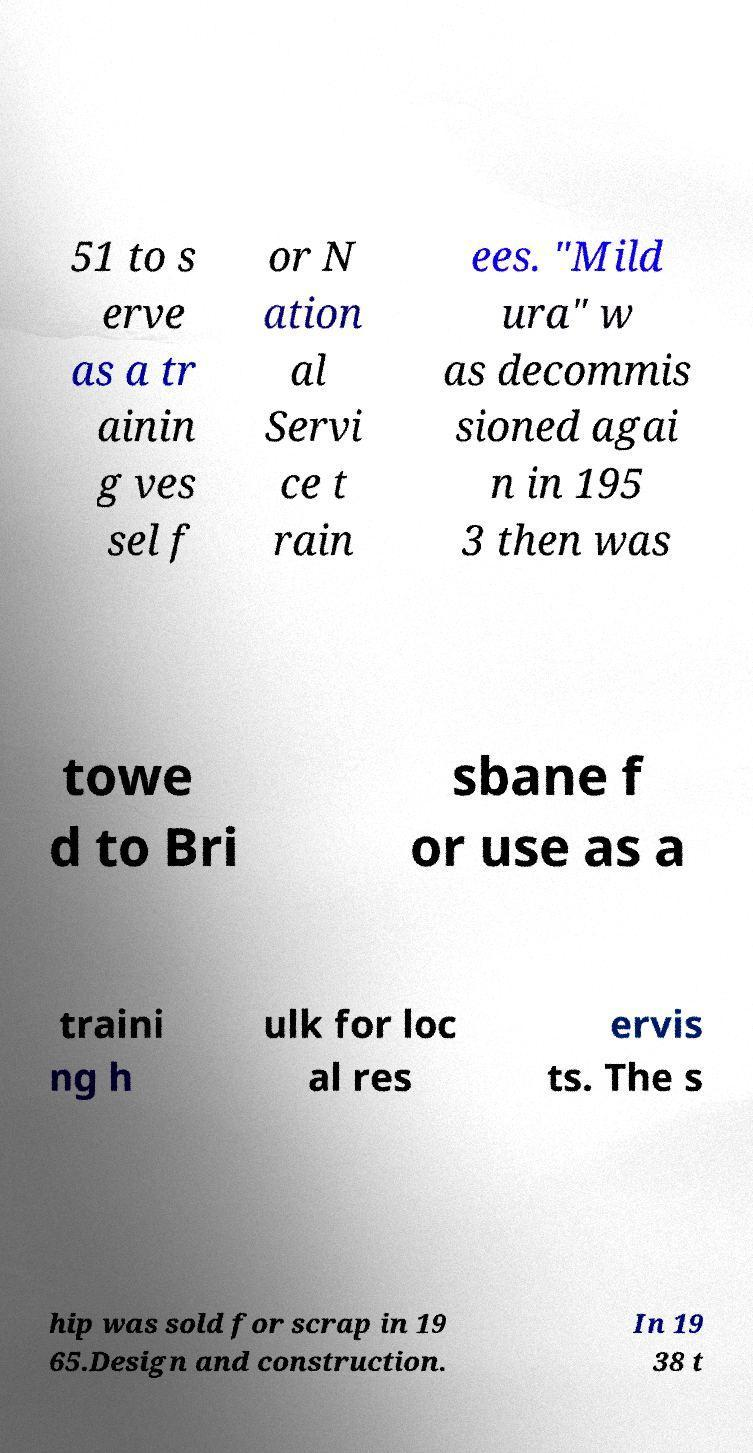Can you read and provide the text displayed in the image?This photo seems to have some interesting text. Can you extract and type it out for me? 51 to s erve as a tr ainin g ves sel f or N ation al Servi ce t rain ees. "Mild ura" w as decommis sioned agai n in 195 3 then was towe d to Bri sbane f or use as a traini ng h ulk for loc al res ervis ts. The s hip was sold for scrap in 19 65.Design and construction. In 19 38 t 